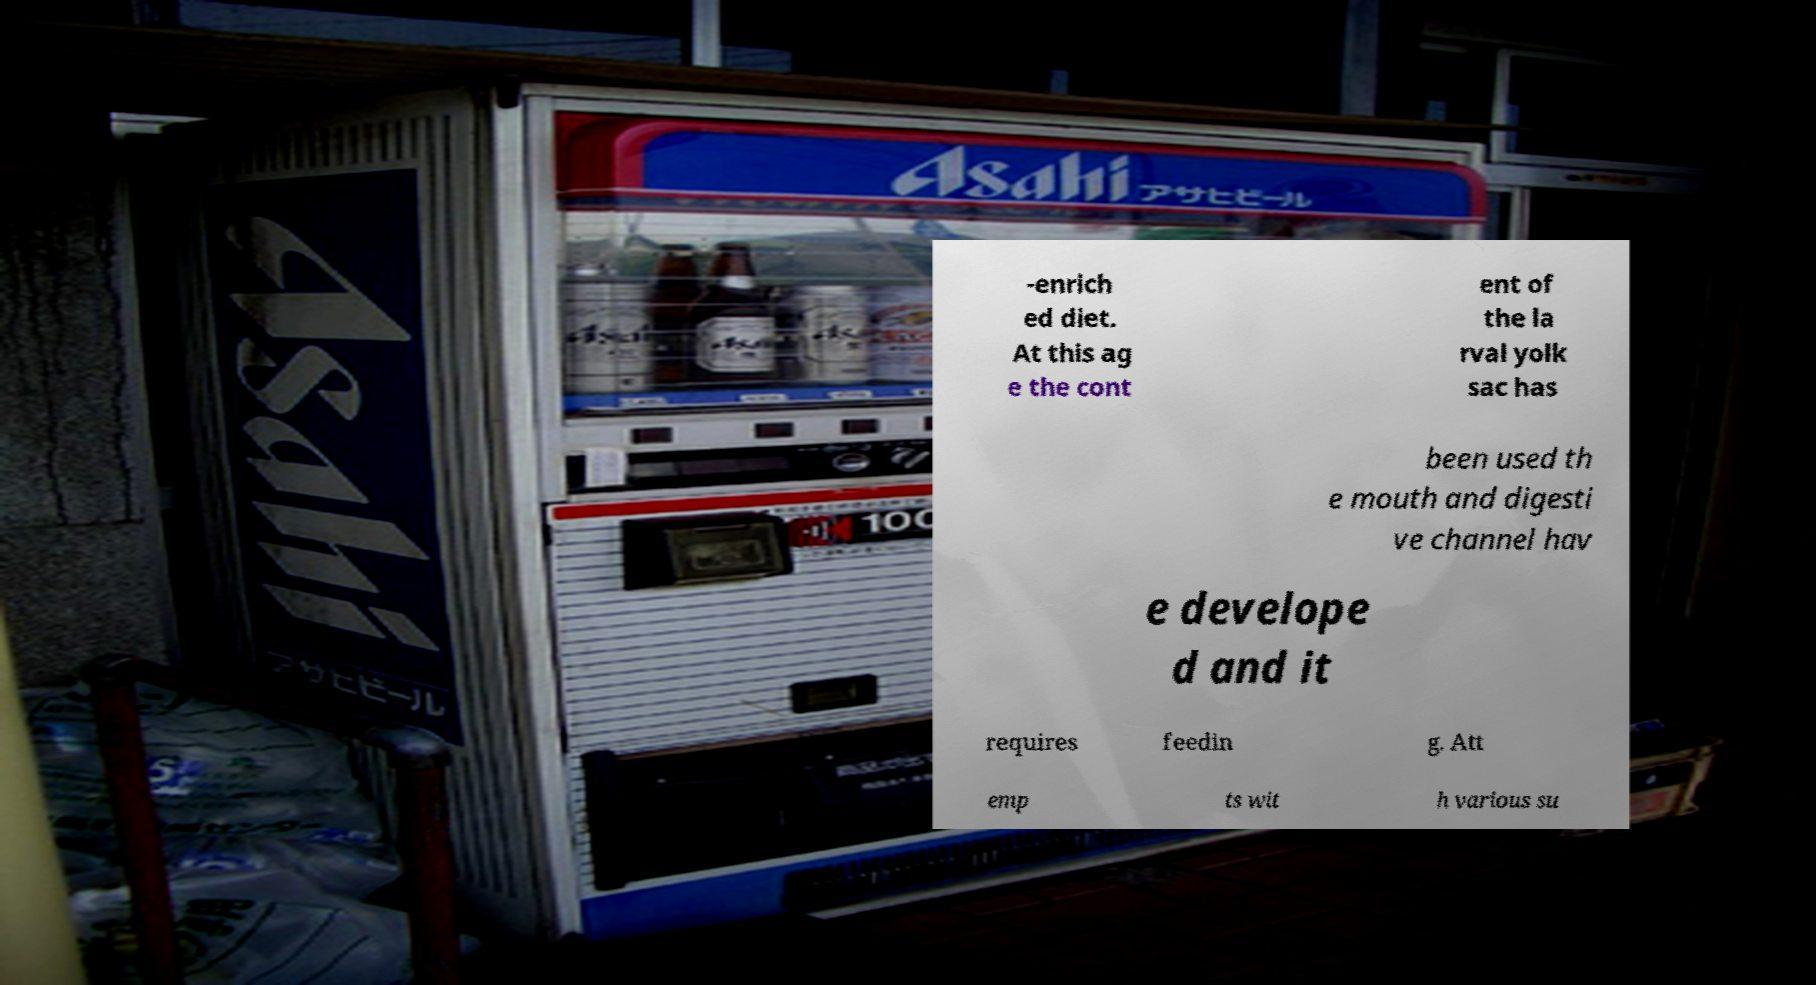Can you accurately transcribe the text from the provided image for me? -enrich ed diet. At this ag e the cont ent of the la rval yolk sac has been used th e mouth and digesti ve channel hav e develope d and it requires feedin g. Att emp ts wit h various su 